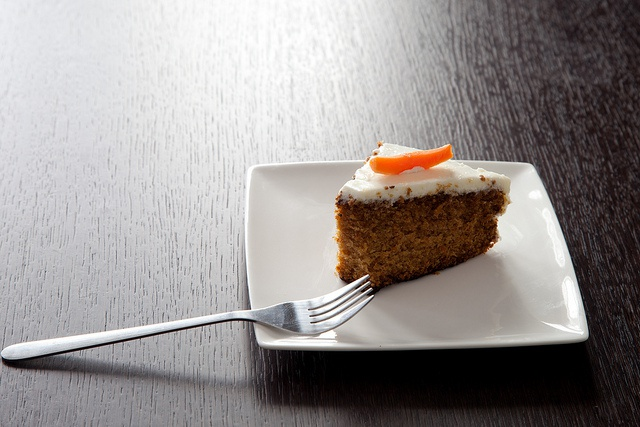Describe the objects in this image and their specific colors. I can see dining table in lightgray, black, darkgray, gray, and maroon tones, cake in white, maroon, black, ivory, and tan tones, fork in white, lightgray, darkgray, gray, and black tones, and carrot in white, red, orange, and tan tones in this image. 